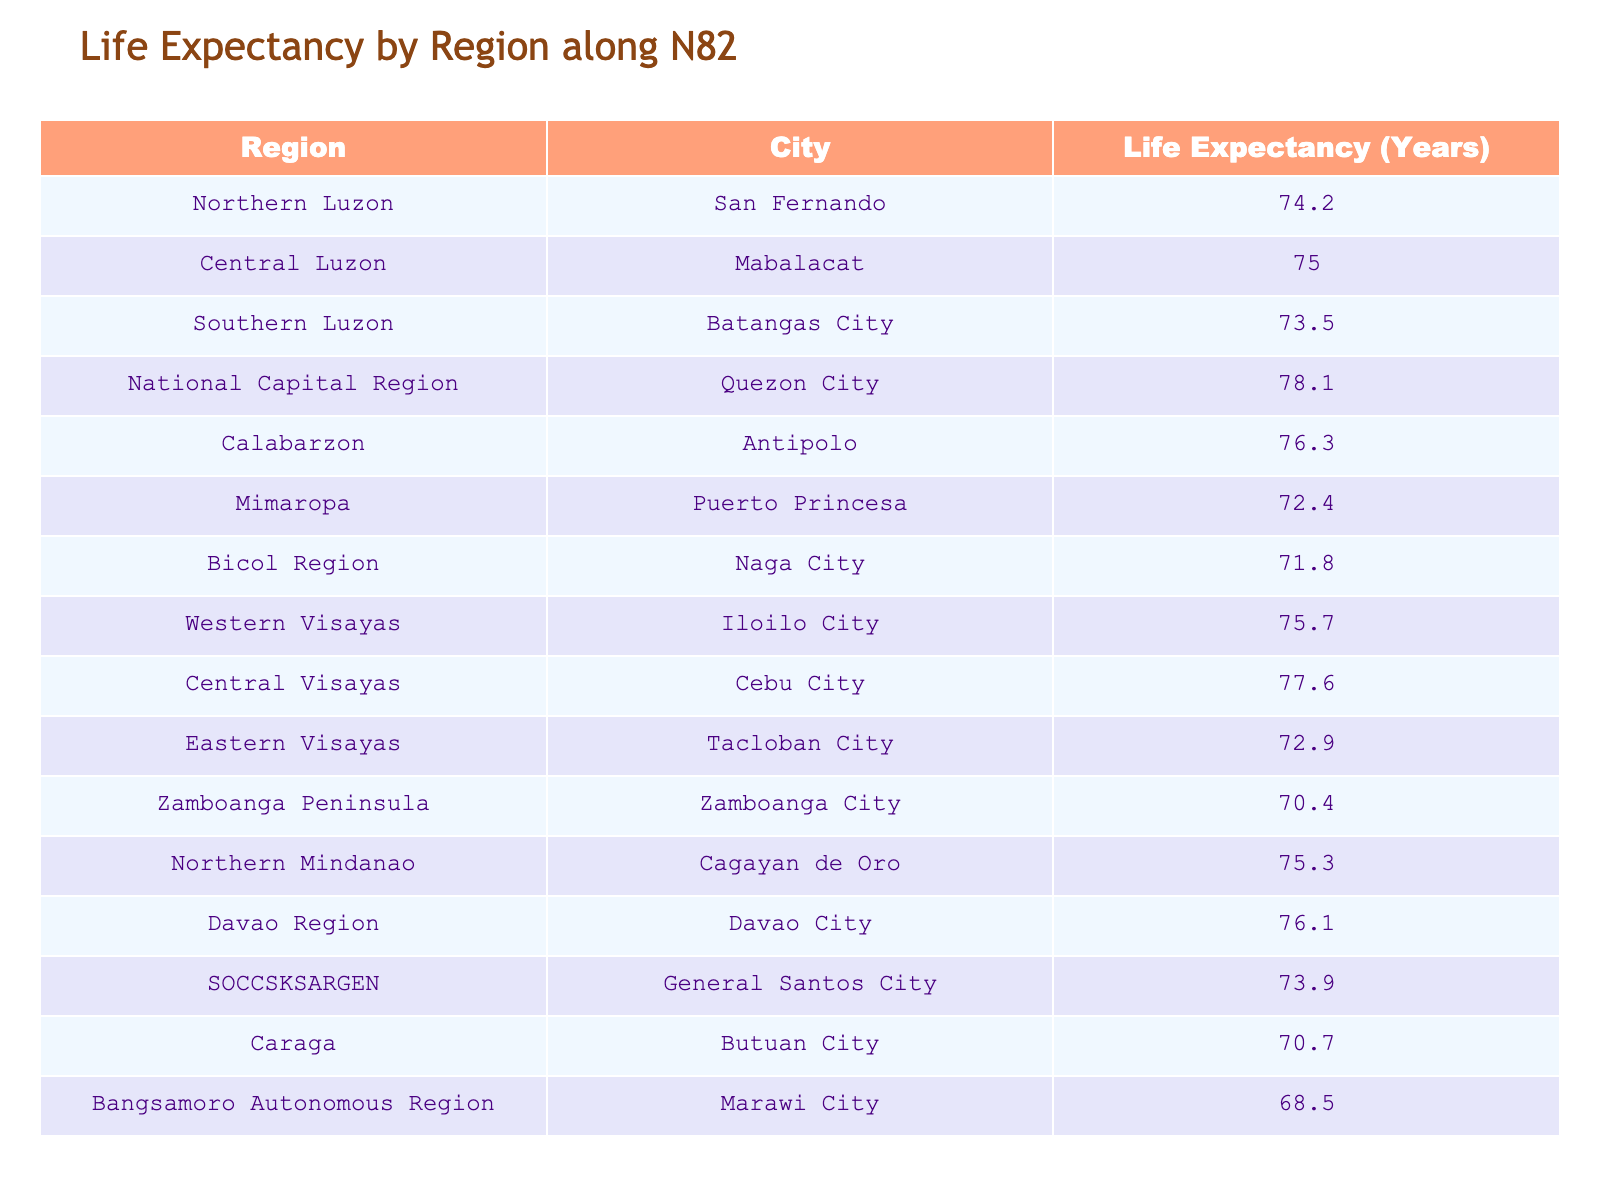What is the life expectancy in Quezon City? From the table, looking specifically for the row containing Quezon City under the National Capital Region, the entry for life expectancy is 78.1 years.
Answer: 78.1 Which region has the lowest life expectancy? By examining the life expectancy values across all regions, Marawi City in the Bangsamoro Autonomous Region has the lowest recorded life expectancy of 68.5 years.
Answer: 68.5 What is the average life expectancy for cities in Northern and Southern Luzon? First, identify the life expectancy for Northern Luzon (74.2) and Southern Luzon (73.5). The sum is 74.2 + 73.5 = 147.7. To find the average, divide by 2, resulting in 147.7 / 2 = 73.85.
Answer: 73.85 Is the life expectancy in Cebu City greater than 75 years? Looking at the row for Cebu City, the life expectancy is 77.6 years, which is indeed greater than 75 years.
Answer: Yes How much higher is the life expectancy in Central Visayas compared to Zamboanga Peninsula? Central Visayas (Cebu City) has a life expectancy of 77.6 years, while the Zamboanga Peninsula (Zamboanga City) has 70.4 years. The difference is calculated as 77.6 - 70.4 = 7.2 years, indicating that Central Visayas has a higher life expectancy by this amount.
Answer: 7.2 years Which city in Calabarzon has a higher life expectancy, Antipolo or Batangas City? The life expectancy for Antipolo is 76.3 years, while Batangas City is 73.5 years. Since 76.3 is greater than 73.5, Antipolo has a higher life expectancy.
Answer: Antipolo What is the total life expectancy for all regions listed? Summing the life expectancy values from each row gives: 74.2 + 75.0 + 73.5 + 78.1 + 76.3 + 72.4 + 71.8 + 75.7 + 77.6 + 72.9 + 70.4 + 75.3 + 76.1 + 73.9 + 70.7 + 68.5 = 1,184.6 years.
Answer: 1184.6 Is the life expectancy in Puerto Princesa lower than the average life expectancy of Visayas regions? The average life expectancy for the Visayas regions (Iloilo City: 75.7, Cebu City: 77.6, Tacloban City: 72.9) is calculated as (75.7 + 77.6 + 72.9) / 3 = 75.4 years. Since Puerto Princesa has a life expectancy of 72.4 years, it is indeed lower than 75.4.
Answer: Yes 